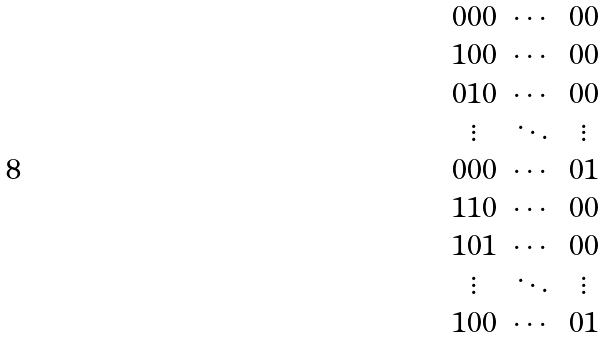Convert formula to latex. <formula><loc_0><loc_0><loc_500><loc_500>\begin{array} { c c c } 0 0 0 & \cdots & 0 0 \\ 1 0 0 & \cdots & 0 0 \\ 0 1 0 & \cdots & 0 0 \\ \vdots & \ddots & \vdots \\ 0 0 0 & \cdots & 0 1 \\ 1 1 0 & \cdots & 0 0 \\ 1 0 1 & \cdots & 0 0 \\ \vdots & \ddots & \vdots \\ 1 0 0 & \cdots & 0 1 \\ \end{array}</formula> 